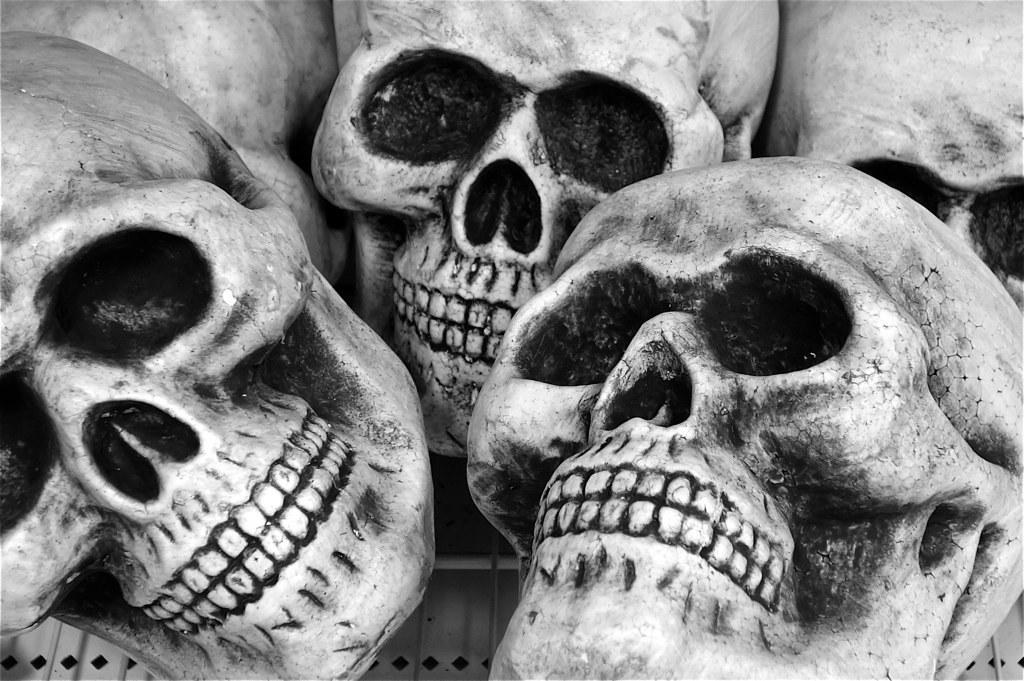Describe this image in one or two sentences. This is a black and white pic. There are skulls on a welded wire mesh on a platform. 